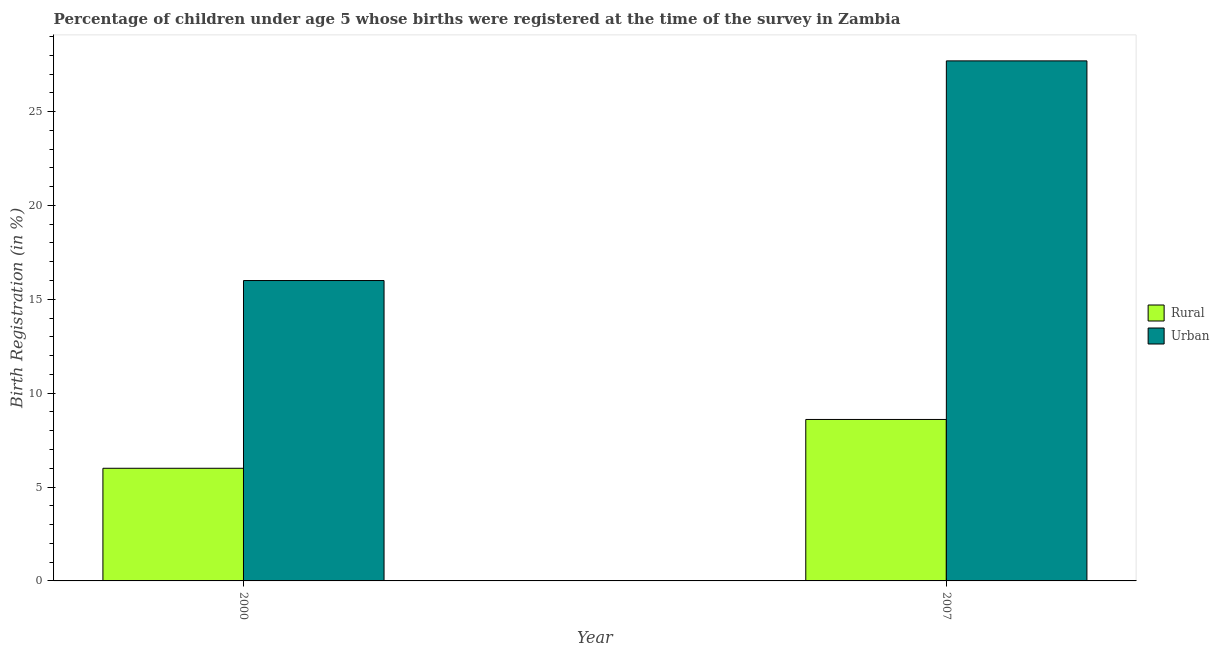How many different coloured bars are there?
Your answer should be very brief. 2. In how many cases, is the number of bars for a given year not equal to the number of legend labels?
Your response must be concise. 0. Across all years, what is the maximum urban birth registration?
Provide a short and direct response. 27.7. Across all years, what is the minimum rural birth registration?
Your answer should be very brief. 6. In which year was the rural birth registration maximum?
Your response must be concise. 2007. In which year was the rural birth registration minimum?
Your response must be concise. 2000. What is the total urban birth registration in the graph?
Make the answer very short. 43.7. What is the difference between the rural birth registration in 2000 and that in 2007?
Your answer should be very brief. -2.6. What is the difference between the rural birth registration in 2000 and the urban birth registration in 2007?
Offer a very short reply. -2.6. What is the average urban birth registration per year?
Offer a very short reply. 21.85. In the year 2007, what is the difference between the rural birth registration and urban birth registration?
Offer a very short reply. 0. In how many years, is the rural birth registration greater than 6 %?
Offer a terse response. 1. What is the ratio of the urban birth registration in 2000 to that in 2007?
Your answer should be very brief. 0.58. In how many years, is the rural birth registration greater than the average rural birth registration taken over all years?
Your answer should be compact. 1. What does the 1st bar from the left in 2000 represents?
Offer a very short reply. Rural. What does the 1st bar from the right in 2007 represents?
Make the answer very short. Urban. How many bars are there?
Offer a terse response. 4. Are all the bars in the graph horizontal?
Make the answer very short. No. What is the difference between two consecutive major ticks on the Y-axis?
Provide a short and direct response. 5. Are the values on the major ticks of Y-axis written in scientific E-notation?
Offer a terse response. No. Does the graph contain grids?
Offer a very short reply. No. Where does the legend appear in the graph?
Provide a succinct answer. Center right. How are the legend labels stacked?
Provide a succinct answer. Vertical. What is the title of the graph?
Make the answer very short. Percentage of children under age 5 whose births were registered at the time of the survey in Zambia. What is the label or title of the Y-axis?
Ensure brevity in your answer.  Birth Registration (in %). What is the Birth Registration (in %) of Rural in 2007?
Offer a very short reply. 8.6. What is the Birth Registration (in %) in Urban in 2007?
Ensure brevity in your answer.  27.7. Across all years, what is the maximum Birth Registration (in %) in Urban?
Make the answer very short. 27.7. Across all years, what is the minimum Birth Registration (in %) of Rural?
Make the answer very short. 6. Across all years, what is the minimum Birth Registration (in %) in Urban?
Make the answer very short. 16. What is the total Birth Registration (in %) in Urban in the graph?
Provide a succinct answer. 43.7. What is the difference between the Birth Registration (in %) of Rural in 2000 and the Birth Registration (in %) of Urban in 2007?
Give a very brief answer. -21.7. What is the average Birth Registration (in %) of Rural per year?
Make the answer very short. 7.3. What is the average Birth Registration (in %) in Urban per year?
Provide a succinct answer. 21.85. In the year 2007, what is the difference between the Birth Registration (in %) of Rural and Birth Registration (in %) of Urban?
Provide a short and direct response. -19.1. What is the ratio of the Birth Registration (in %) of Rural in 2000 to that in 2007?
Your response must be concise. 0.7. What is the ratio of the Birth Registration (in %) in Urban in 2000 to that in 2007?
Your answer should be very brief. 0.58. 